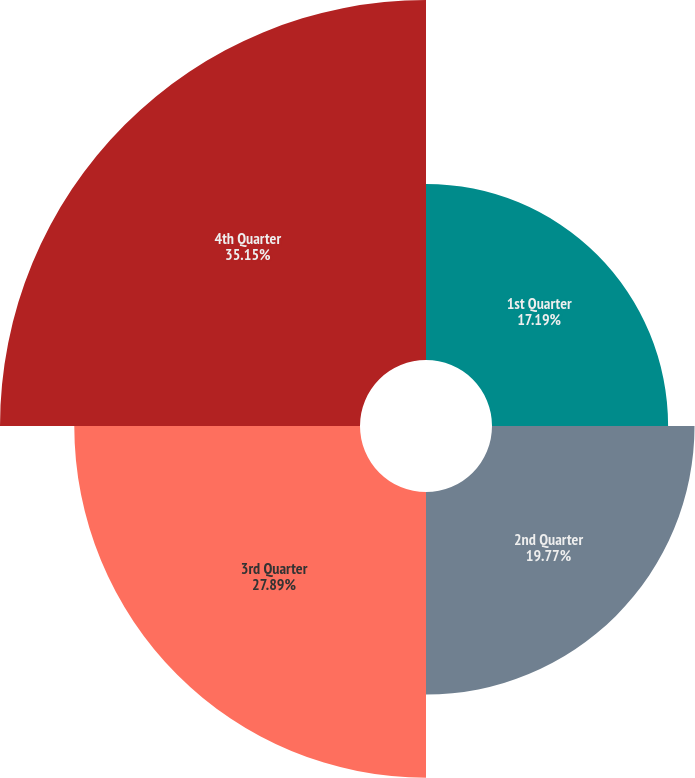<chart> <loc_0><loc_0><loc_500><loc_500><pie_chart><fcel>1st Quarter<fcel>2nd Quarter<fcel>3rd Quarter<fcel>4th Quarter<nl><fcel>17.19%<fcel>19.77%<fcel>27.89%<fcel>35.14%<nl></chart> 